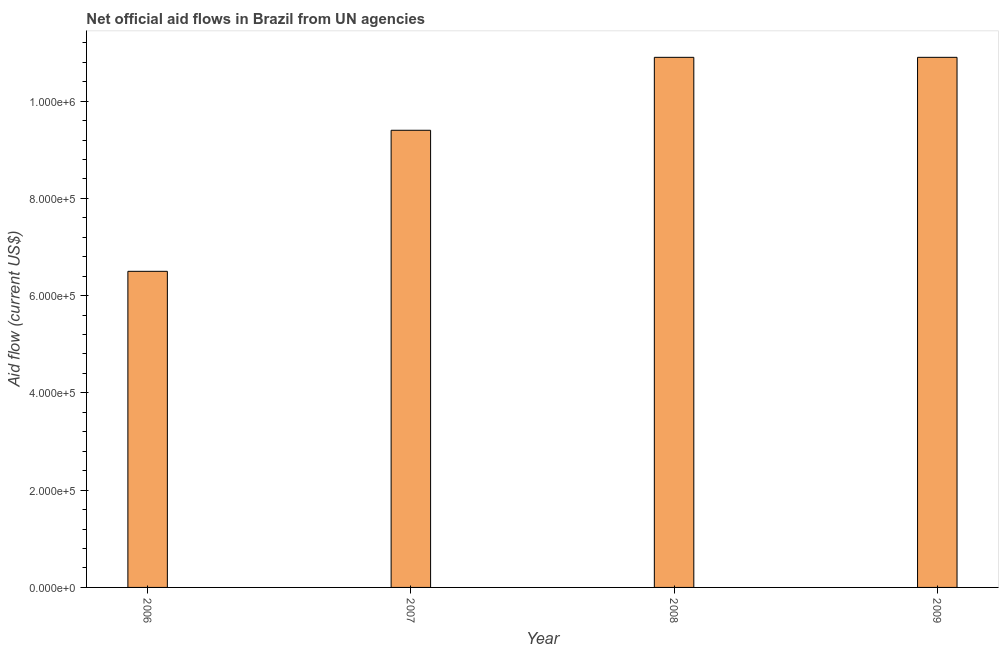Does the graph contain any zero values?
Offer a terse response. No. Does the graph contain grids?
Give a very brief answer. No. What is the title of the graph?
Ensure brevity in your answer.  Net official aid flows in Brazil from UN agencies. What is the net official flows from un agencies in 2006?
Give a very brief answer. 6.50e+05. Across all years, what is the maximum net official flows from un agencies?
Your answer should be very brief. 1.09e+06. Across all years, what is the minimum net official flows from un agencies?
Make the answer very short. 6.50e+05. What is the sum of the net official flows from un agencies?
Make the answer very short. 3.77e+06. What is the difference between the net official flows from un agencies in 2006 and 2007?
Provide a succinct answer. -2.90e+05. What is the average net official flows from un agencies per year?
Ensure brevity in your answer.  9.42e+05. What is the median net official flows from un agencies?
Provide a succinct answer. 1.02e+06. Do a majority of the years between 2006 and 2007 (inclusive) have net official flows from un agencies greater than 360000 US$?
Offer a terse response. Yes. What is the ratio of the net official flows from un agencies in 2006 to that in 2008?
Make the answer very short. 0.6. Is the sum of the net official flows from un agencies in 2008 and 2009 greater than the maximum net official flows from un agencies across all years?
Provide a succinct answer. Yes. What is the difference between the highest and the lowest net official flows from un agencies?
Ensure brevity in your answer.  4.40e+05. How many years are there in the graph?
Make the answer very short. 4. What is the difference between two consecutive major ticks on the Y-axis?
Provide a succinct answer. 2.00e+05. What is the Aid flow (current US$) in 2006?
Your answer should be compact. 6.50e+05. What is the Aid flow (current US$) in 2007?
Give a very brief answer. 9.40e+05. What is the Aid flow (current US$) of 2008?
Make the answer very short. 1.09e+06. What is the Aid flow (current US$) in 2009?
Make the answer very short. 1.09e+06. What is the difference between the Aid flow (current US$) in 2006 and 2008?
Your answer should be very brief. -4.40e+05. What is the difference between the Aid flow (current US$) in 2006 and 2009?
Your response must be concise. -4.40e+05. What is the difference between the Aid flow (current US$) in 2007 and 2008?
Provide a succinct answer. -1.50e+05. What is the ratio of the Aid flow (current US$) in 2006 to that in 2007?
Make the answer very short. 0.69. What is the ratio of the Aid flow (current US$) in 2006 to that in 2008?
Offer a very short reply. 0.6. What is the ratio of the Aid flow (current US$) in 2006 to that in 2009?
Offer a very short reply. 0.6. What is the ratio of the Aid flow (current US$) in 2007 to that in 2008?
Offer a very short reply. 0.86. What is the ratio of the Aid flow (current US$) in 2007 to that in 2009?
Offer a very short reply. 0.86. 